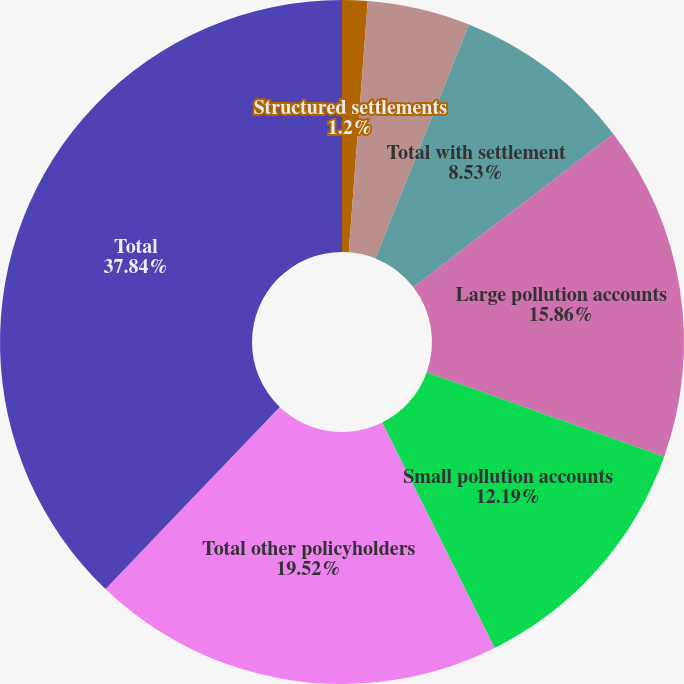<chart> <loc_0><loc_0><loc_500><loc_500><pie_chart><fcel>Structured settlements<fcel>Coverage in place<fcel>Total with settlement<fcel>Large pollution accounts<fcel>Small pollution accounts<fcel>Total other policyholders<fcel>Total<nl><fcel>1.2%<fcel>4.86%<fcel>8.53%<fcel>15.86%<fcel>12.19%<fcel>19.52%<fcel>37.85%<nl></chart> 